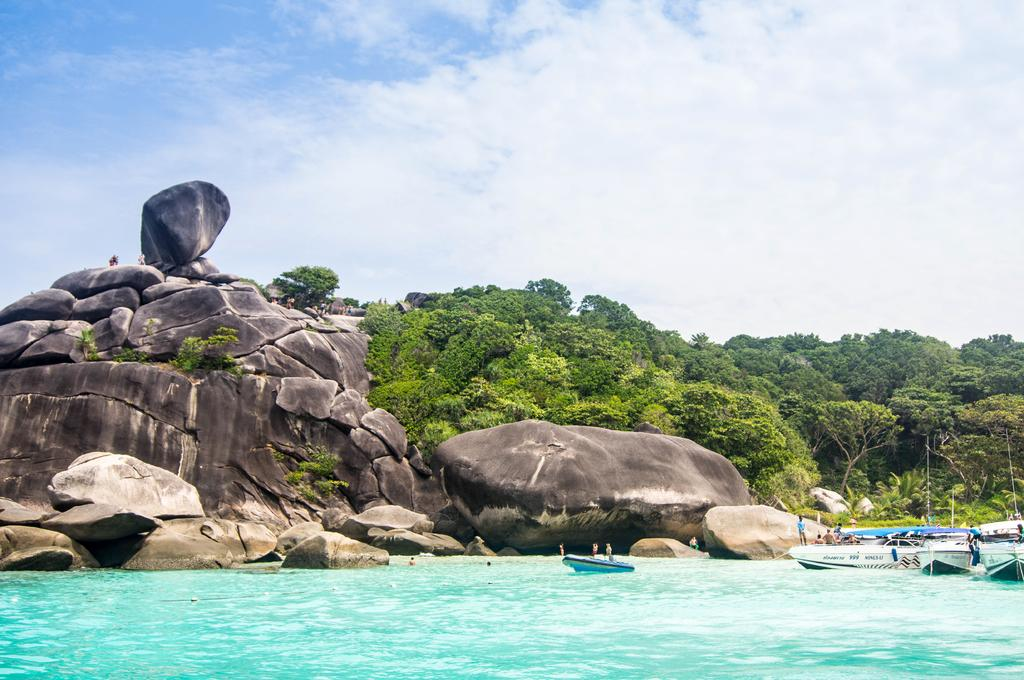What is in the water in the image? There are boats in the water. Who or what is in the boats? There are people in the boats. What can be seen in the background of the image? There are rocks and many trees visible in the background. What is visible in the sky in the image? There are clouds in the sky, and the sky is visible in the background. Can you see a ladybug playing basketball on one of the boats in the image? No, there is no ladybug or basketball present in the image. The image only features boats, people, rocks, trees, clouds, and the sky. 